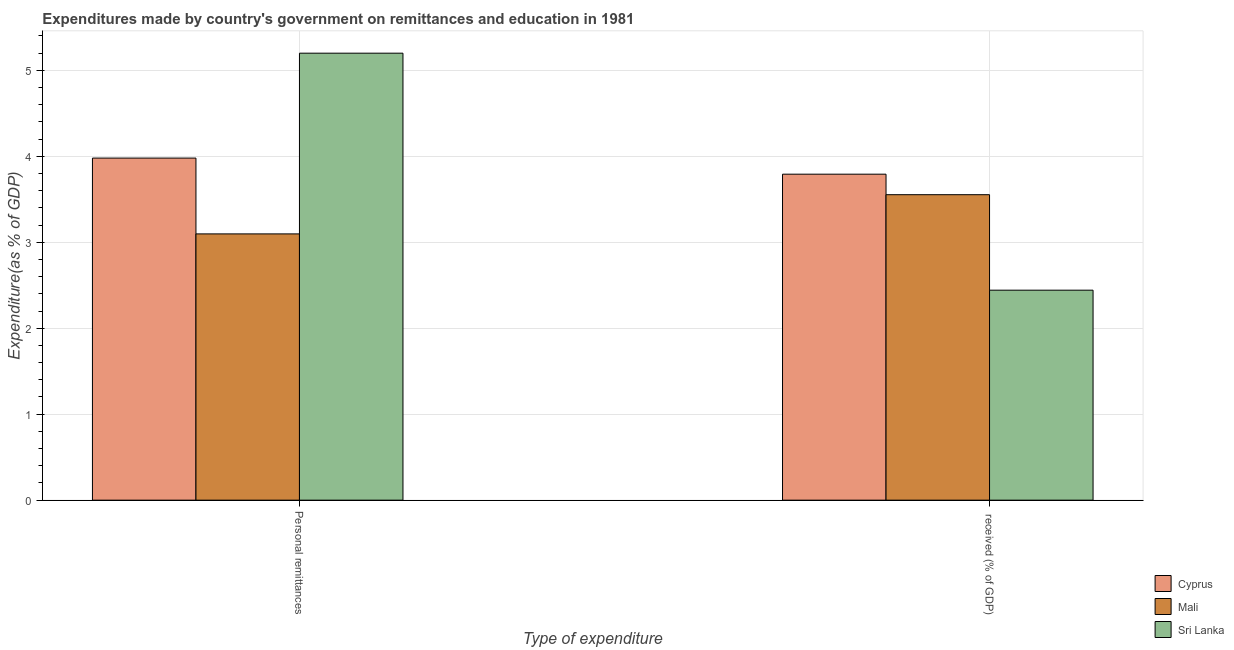How many different coloured bars are there?
Provide a succinct answer. 3. How many groups of bars are there?
Offer a terse response. 2. Are the number of bars per tick equal to the number of legend labels?
Provide a short and direct response. Yes. How many bars are there on the 2nd tick from the left?
Give a very brief answer. 3. What is the label of the 2nd group of bars from the left?
Offer a terse response.  received (% of GDP). What is the expenditure in personal remittances in Sri Lanka?
Offer a terse response. 5.2. Across all countries, what is the maximum expenditure in education?
Your answer should be very brief. 3.79. Across all countries, what is the minimum expenditure in personal remittances?
Offer a terse response. 3.1. In which country was the expenditure in education maximum?
Keep it short and to the point. Cyprus. In which country was the expenditure in education minimum?
Provide a short and direct response. Sri Lanka. What is the total expenditure in education in the graph?
Your response must be concise. 9.79. What is the difference between the expenditure in personal remittances in Mali and that in Cyprus?
Your answer should be compact. -0.88. What is the difference between the expenditure in personal remittances in Mali and the expenditure in education in Sri Lanka?
Keep it short and to the point. 0.65. What is the average expenditure in education per country?
Make the answer very short. 3.26. What is the difference between the expenditure in education and expenditure in personal remittances in Sri Lanka?
Provide a short and direct response. -2.76. What is the ratio of the expenditure in education in Mali to that in Cyprus?
Your answer should be compact. 0.94. In how many countries, is the expenditure in education greater than the average expenditure in education taken over all countries?
Offer a terse response. 2. What does the 1st bar from the left in  received (% of GDP) represents?
Give a very brief answer. Cyprus. What does the 1st bar from the right in Personal remittances represents?
Give a very brief answer. Sri Lanka. Are all the bars in the graph horizontal?
Your answer should be compact. No. How many countries are there in the graph?
Offer a terse response. 3. What is the difference between two consecutive major ticks on the Y-axis?
Your answer should be very brief. 1. Are the values on the major ticks of Y-axis written in scientific E-notation?
Provide a succinct answer. No. Does the graph contain any zero values?
Give a very brief answer. No. How many legend labels are there?
Make the answer very short. 3. What is the title of the graph?
Provide a succinct answer. Expenditures made by country's government on remittances and education in 1981. What is the label or title of the X-axis?
Your answer should be very brief. Type of expenditure. What is the label or title of the Y-axis?
Your answer should be very brief. Expenditure(as % of GDP). What is the Expenditure(as % of GDP) in Cyprus in Personal remittances?
Give a very brief answer. 3.98. What is the Expenditure(as % of GDP) in Mali in Personal remittances?
Offer a very short reply. 3.1. What is the Expenditure(as % of GDP) in Sri Lanka in Personal remittances?
Offer a very short reply. 5.2. What is the Expenditure(as % of GDP) in Cyprus in  received (% of GDP)?
Offer a terse response. 3.79. What is the Expenditure(as % of GDP) in Mali in  received (% of GDP)?
Offer a very short reply. 3.55. What is the Expenditure(as % of GDP) in Sri Lanka in  received (% of GDP)?
Your answer should be very brief. 2.44. Across all Type of expenditure, what is the maximum Expenditure(as % of GDP) in Cyprus?
Give a very brief answer. 3.98. Across all Type of expenditure, what is the maximum Expenditure(as % of GDP) in Mali?
Ensure brevity in your answer.  3.55. Across all Type of expenditure, what is the maximum Expenditure(as % of GDP) in Sri Lanka?
Your answer should be very brief. 5.2. Across all Type of expenditure, what is the minimum Expenditure(as % of GDP) of Cyprus?
Give a very brief answer. 3.79. Across all Type of expenditure, what is the minimum Expenditure(as % of GDP) in Mali?
Ensure brevity in your answer.  3.1. Across all Type of expenditure, what is the minimum Expenditure(as % of GDP) in Sri Lanka?
Your answer should be compact. 2.44. What is the total Expenditure(as % of GDP) of Cyprus in the graph?
Your response must be concise. 7.77. What is the total Expenditure(as % of GDP) of Mali in the graph?
Provide a short and direct response. 6.65. What is the total Expenditure(as % of GDP) in Sri Lanka in the graph?
Provide a short and direct response. 7.64. What is the difference between the Expenditure(as % of GDP) of Cyprus in Personal remittances and that in  received (% of GDP)?
Keep it short and to the point. 0.19. What is the difference between the Expenditure(as % of GDP) of Mali in Personal remittances and that in  received (% of GDP)?
Offer a very short reply. -0.46. What is the difference between the Expenditure(as % of GDP) of Sri Lanka in Personal remittances and that in  received (% of GDP)?
Keep it short and to the point. 2.76. What is the difference between the Expenditure(as % of GDP) in Cyprus in Personal remittances and the Expenditure(as % of GDP) in Mali in  received (% of GDP)?
Your answer should be very brief. 0.43. What is the difference between the Expenditure(as % of GDP) in Cyprus in Personal remittances and the Expenditure(as % of GDP) in Sri Lanka in  received (% of GDP)?
Make the answer very short. 1.54. What is the difference between the Expenditure(as % of GDP) of Mali in Personal remittances and the Expenditure(as % of GDP) of Sri Lanka in  received (% of GDP)?
Ensure brevity in your answer.  0.65. What is the average Expenditure(as % of GDP) of Cyprus per Type of expenditure?
Offer a terse response. 3.88. What is the average Expenditure(as % of GDP) of Mali per Type of expenditure?
Give a very brief answer. 3.32. What is the average Expenditure(as % of GDP) of Sri Lanka per Type of expenditure?
Make the answer very short. 3.82. What is the difference between the Expenditure(as % of GDP) in Cyprus and Expenditure(as % of GDP) in Mali in Personal remittances?
Offer a terse response. 0.88. What is the difference between the Expenditure(as % of GDP) of Cyprus and Expenditure(as % of GDP) of Sri Lanka in Personal remittances?
Offer a very short reply. -1.22. What is the difference between the Expenditure(as % of GDP) in Mali and Expenditure(as % of GDP) in Sri Lanka in Personal remittances?
Your answer should be very brief. -2.1. What is the difference between the Expenditure(as % of GDP) of Cyprus and Expenditure(as % of GDP) of Mali in  received (% of GDP)?
Your response must be concise. 0.24. What is the difference between the Expenditure(as % of GDP) in Cyprus and Expenditure(as % of GDP) in Sri Lanka in  received (% of GDP)?
Offer a very short reply. 1.35. What is the difference between the Expenditure(as % of GDP) in Mali and Expenditure(as % of GDP) in Sri Lanka in  received (% of GDP)?
Your answer should be compact. 1.11. What is the ratio of the Expenditure(as % of GDP) in Cyprus in Personal remittances to that in  received (% of GDP)?
Provide a succinct answer. 1.05. What is the ratio of the Expenditure(as % of GDP) in Mali in Personal remittances to that in  received (% of GDP)?
Offer a very short reply. 0.87. What is the ratio of the Expenditure(as % of GDP) of Sri Lanka in Personal remittances to that in  received (% of GDP)?
Your response must be concise. 2.13. What is the difference between the highest and the second highest Expenditure(as % of GDP) of Cyprus?
Give a very brief answer. 0.19. What is the difference between the highest and the second highest Expenditure(as % of GDP) in Mali?
Your answer should be compact. 0.46. What is the difference between the highest and the second highest Expenditure(as % of GDP) of Sri Lanka?
Make the answer very short. 2.76. What is the difference between the highest and the lowest Expenditure(as % of GDP) of Cyprus?
Offer a terse response. 0.19. What is the difference between the highest and the lowest Expenditure(as % of GDP) in Mali?
Your answer should be very brief. 0.46. What is the difference between the highest and the lowest Expenditure(as % of GDP) of Sri Lanka?
Ensure brevity in your answer.  2.76. 